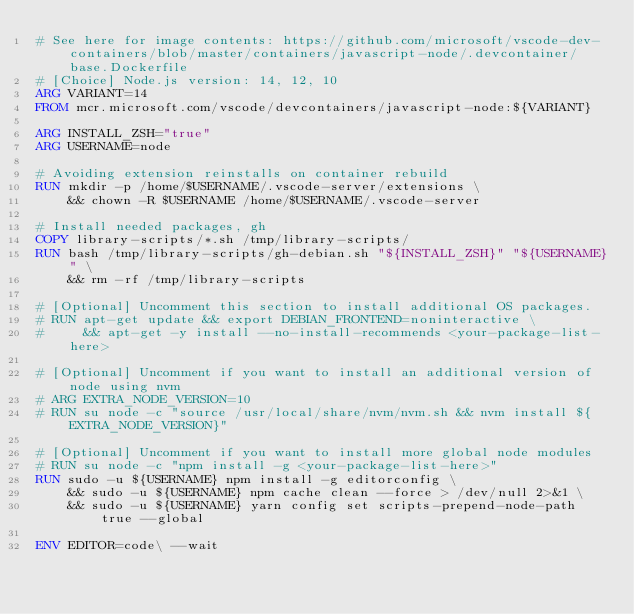Convert code to text. <code><loc_0><loc_0><loc_500><loc_500><_Dockerfile_># See here for image contents: https://github.com/microsoft/vscode-dev-containers/blob/master/containers/javascript-node/.devcontainer/base.Dockerfile
# [Choice] Node.js version: 14, 12, 10
ARG VARIANT=14
FROM mcr.microsoft.com/vscode/devcontainers/javascript-node:${VARIANT}

ARG INSTALL_ZSH="true"
ARG USERNAME=node

# Avoiding extension reinstalls on container rebuild
RUN mkdir -p /home/$USERNAME/.vscode-server/extensions \
    && chown -R $USERNAME /home/$USERNAME/.vscode-server

# Install needed packages, gh
COPY library-scripts/*.sh /tmp/library-scripts/
RUN bash /tmp/library-scripts/gh-debian.sh "${INSTALL_ZSH}" "${USERNAME}" \
    && rm -rf /tmp/library-scripts

# [Optional] Uncomment this section to install additional OS packages.
# RUN apt-get update && export DEBIAN_FRONTEND=noninteractive \
#     && apt-get -y install --no-install-recommends <your-package-list-here>

# [Optional] Uncomment if you want to install an additional version of node using nvm
# ARG EXTRA_NODE_VERSION=10
# RUN su node -c "source /usr/local/share/nvm/nvm.sh && nvm install ${EXTRA_NODE_VERSION}"

# [Optional] Uncomment if you want to install more global node modules
# RUN su node -c "npm install -g <your-package-list-here>"
RUN sudo -u ${USERNAME} npm install -g editorconfig \
    && sudo -u ${USERNAME} npm cache clean --force > /dev/null 2>&1 \
    && sudo -u ${USERNAME} yarn config set scripts-prepend-node-path true --global

ENV EDITOR=code\ --wait
</code> 